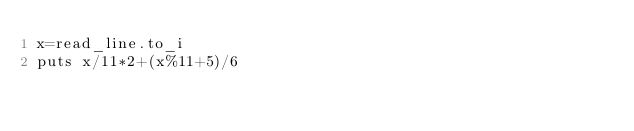Convert code to text. <code><loc_0><loc_0><loc_500><loc_500><_Crystal_>x=read_line.to_i
puts x/11*2+(x%11+5)/6</code> 